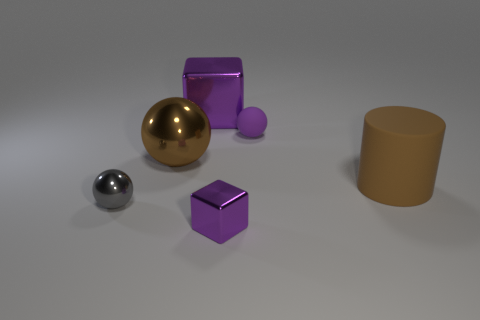Is the gray thing made of the same material as the brown cylinder?
Give a very brief answer. No. How many red things are either shiny cubes or small rubber balls?
Offer a terse response. 0. Are there more brown metal objects that are in front of the large cylinder than yellow cylinders?
Give a very brief answer. No. Are there any large things that have the same color as the matte sphere?
Provide a succinct answer. Yes. How big is the brown matte cylinder?
Keep it short and to the point. Large. Is the big matte cylinder the same color as the large ball?
Give a very brief answer. Yes. How many objects are small brown metallic things or metallic things to the right of the big brown shiny ball?
Offer a terse response. 2. There is a brown object that is left of the tiny purple thing in front of the gray thing; what number of objects are in front of it?
Offer a terse response. 3. What material is the large sphere that is the same color as the big cylinder?
Offer a very short reply. Metal. How many purple things are there?
Offer a very short reply. 3. 